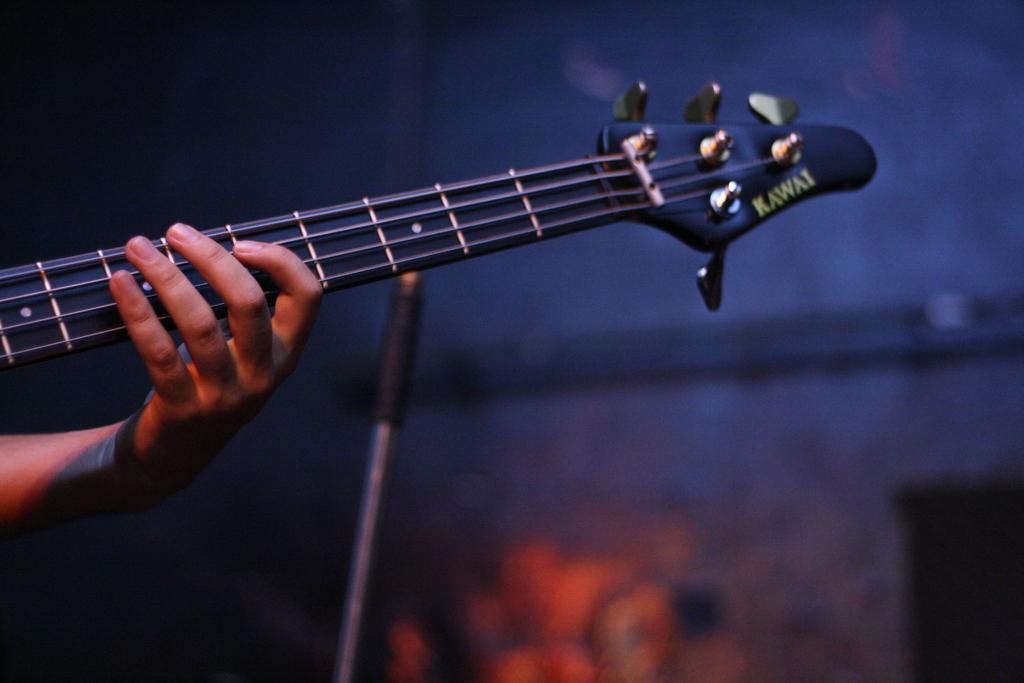How would you summarize this image in a sentence or two? In this picture we can see person's hand holding guitar and in the background we can see some pole, light, wall. 